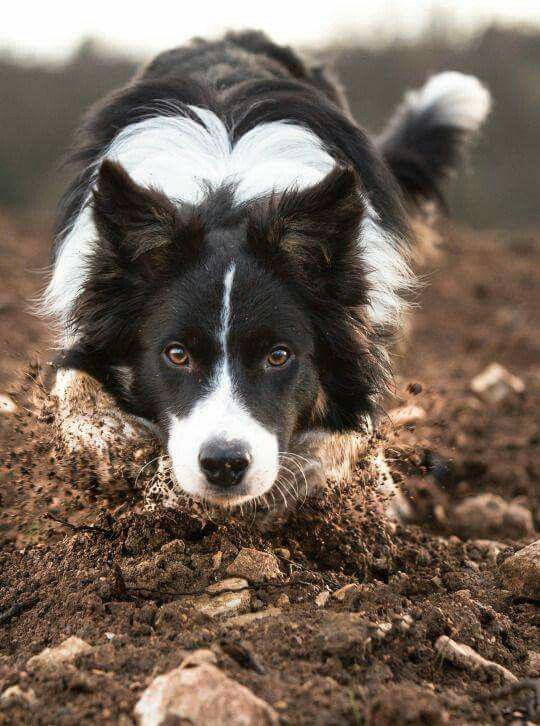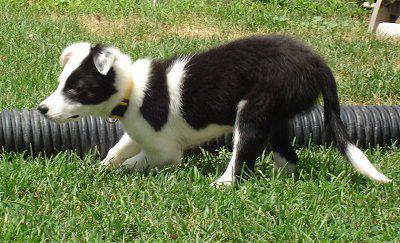The first image is the image on the left, the second image is the image on the right. For the images shown, is this caption "There are two dogs in the image on the right" true? Answer yes or no. No. The first image is the image on the left, the second image is the image on the right. For the images displayed, is the sentence "A dog has at least one paw in the air." factually correct? Answer yes or no. No. 